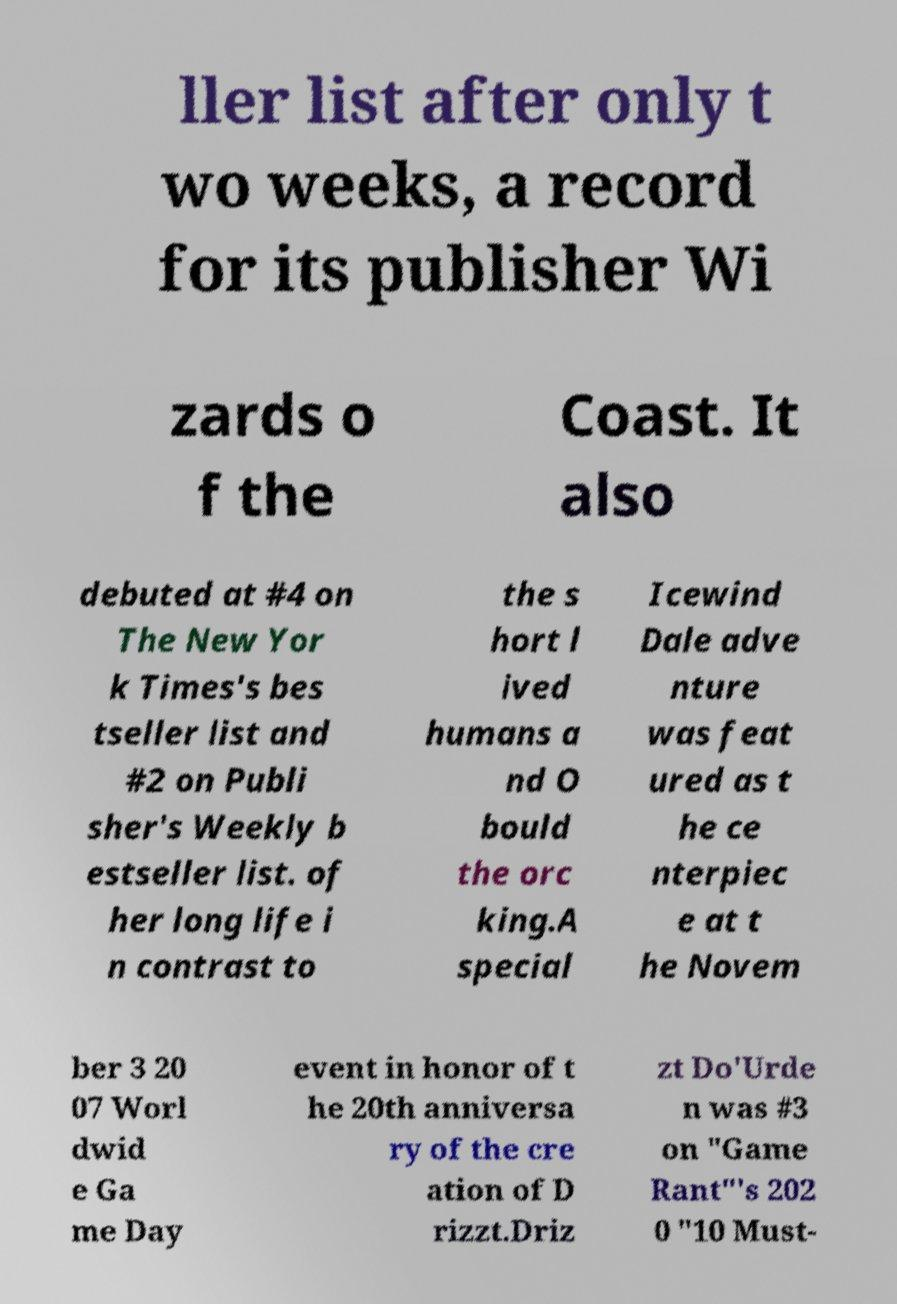For documentation purposes, I need the text within this image transcribed. Could you provide that? ller list after only t wo weeks, a record for its publisher Wi zards o f the Coast. It also debuted at #4 on The New Yor k Times's bes tseller list and #2 on Publi sher's Weekly b estseller list. of her long life i n contrast to the s hort l ived humans a nd O bould the orc king.A special Icewind Dale adve nture was feat ured as t he ce nterpiec e at t he Novem ber 3 20 07 Worl dwid e Ga me Day event in honor of t he 20th anniversa ry of the cre ation of D rizzt.Driz zt Do'Urde n was #3 on "Game Rant"'s 202 0 "10 Must- 